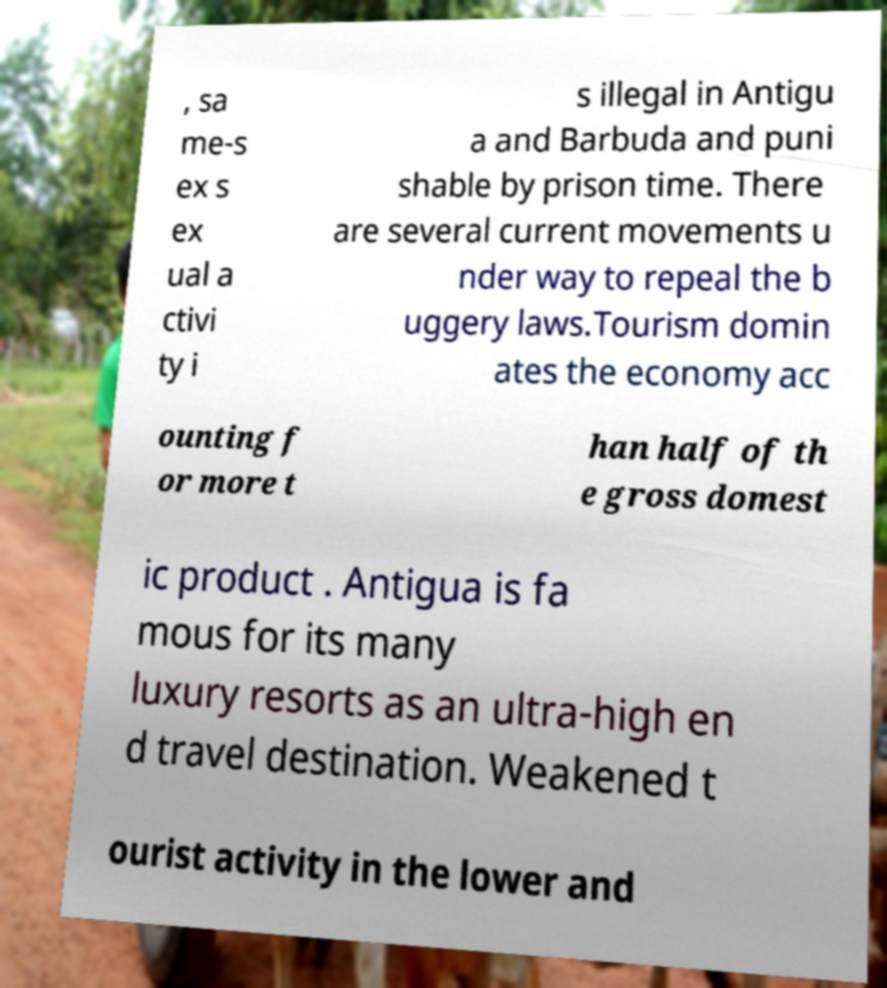Please read and relay the text visible in this image. What does it say? , sa me-s ex s ex ual a ctivi ty i s illegal in Antigu a and Barbuda and puni shable by prison time. There are several current movements u nder way to repeal the b uggery laws.Tourism domin ates the economy acc ounting f or more t han half of th e gross domest ic product . Antigua is fa mous for its many luxury resorts as an ultra-high en d travel destination. Weakened t ourist activity in the lower and 